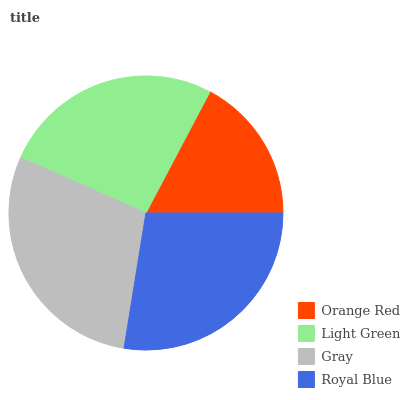Is Orange Red the minimum?
Answer yes or no. Yes. Is Gray the maximum?
Answer yes or no. Yes. Is Light Green the minimum?
Answer yes or no. No. Is Light Green the maximum?
Answer yes or no. No. Is Light Green greater than Orange Red?
Answer yes or no. Yes. Is Orange Red less than Light Green?
Answer yes or no. Yes. Is Orange Red greater than Light Green?
Answer yes or no. No. Is Light Green less than Orange Red?
Answer yes or no. No. Is Royal Blue the high median?
Answer yes or no. Yes. Is Light Green the low median?
Answer yes or no. Yes. Is Gray the high median?
Answer yes or no. No. Is Orange Red the low median?
Answer yes or no. No. 